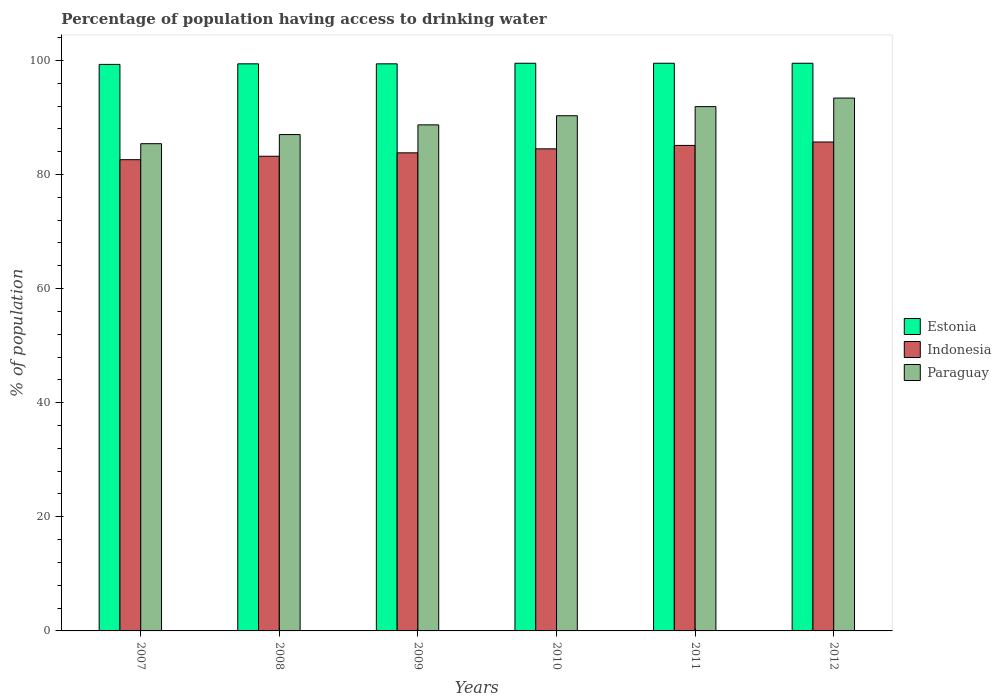How many groups of bars are there?
Give a very brief answer. 6. Are the number of bars per tick equal to the number of legend labels?
Your answer should be compact. Yes. Are the number of bars on each tick of the X-axis equal?
Give a very brief answer. Yes. How many bars are there on the 4th tick from the right?
Keep it short and to the point. 3. What is the percentage of population having access to drinking water in Indonesia in 2008?
Your answer should be very brief. 83.2. Across all years, what is the maximum percentage of population having access to drinking water in Indonesia?
Provide a short and direct response. 85.7. Across all years, what is the minimum percentage of population having access to drinking water in Estonia?
Make the answer very short. 99.3. In which year was the percentage of population having access to drinking water in Indonesia maximum?
Your response must be concise. 2012. What is the total percentage of population having access to drinking water in Indonesia in the graph?
Ensure brevity in your answer.  504.9. What is the difference between the percentage of population having access to drinking water in Indonesia in 2008 and that in 2010?
Give a very brief answer. -1.3. What is the difference between the percentage of population having access to drinking water in Indonesia in 2011 and the percentage of population having access to drinking water in Estonia in 2010?
Offer a very short reply. -14.4. What is the average percentage of population having access to drinking water in Paraguay per year?
Provide a short and direct response. 89.45. In the year 2009, what is the difference between the percentage of population having access to drinking water in Indonesia and percentage of population having access to drinking water in Estonia?
Offer a very short reply. -15.6. In how many years, is the percentage of population having access to drinking water in Paraguay greater than 12 %?
Offer a very short reply. 6. What is the ratio of the percentage of population having access to drinking water in Estonia in 2008 to that in 2012?
Provide a succinct answer. 1. Is the percentage of population having access to drinking water in Estonia in 2007 less than that in 2008?
Make the answer very short. Yes. What is the difference between the highest and the second highest percentage of population having access to drinking water in Indonesia?
Give a very brief answer. 0.6. What is the difference between the highest and the lowest percentage of population having access to drinking water in Estonia?
Offer a very short reply. 0.2. Is the sum of the percentage of population having access to drinking water in Paraguay in 2007 and 2009 greater than the maximum percentage of population having access to drinking water in Indonesia across all years?
Make the answer very short. Yes. What does the 1st bar from the left in 2010 represents?
Your response must be concise. Estonia. What does the 1st bar from the right in 2008 represents?
Ensure brevity in your answer.  Paraguay. How many bars are there?
Your response must be concise. 18. Are all the bars in the graph horizontal?
Ensure brevity in your answer.  No. How many years are there in the graph?
Your answer should be very brief. 6. What is the difference between two consecutive major ticks on the Y-axis?
Ensure brevity in your answer.  20. Are the values on the major ticks of Y-axis written in scientific E-notation?
Provide a short and direct response. No. Does the graph contain any zero values?
Make the answer very short. No. Does the graph contain grids?
Make the answer very short. No. How many legend labels are there?
Offer a terse response. 3. What is the title of the graph?
Provide a succinct answer. Percentage of population having access to drinking water. Does "South Asia" appear as one of the legend labels in the graph?
Your answer should be compact. No. What is the label or title of the X-axis?
Your response must be concise. Years. What is the label or title of the Y-axis?
Your response must be concise. % of population. What is the % of population of Estonia in 2007?
Provide a short and direct response. 99.3. What is the % of population of Indonesia in 2007?
Your answer should be compact. 82.6. What is the % of population of Paraguay in 2007?
Ensure brevity in your answer.  85.4. What is the % of population in Estonia in 2008?
Provide a succinct answer. 99.4. What is the % of population of Indonesia in 2008?
Offer a very short reply. 83.2. What is the % of population of Paraguay in 2008?
Ensure brevity in your answer.  87. What is the % of population of Estonia in 2009?
Ensure brevity in your answer.  99.4. What is the % of population in Indonesia in 2009?
Provide a short and direct response. 83.8. What is the % of population in Paraguay in 2009?
Provide a succinct answer. 88.7. What is the % of population of Estonia in 2010?
Keep it short and to the point. 99.5. What is the % of population of Indonesia in 2010?
Offer a terse response. 84.5. What is the % of population in Paraguay in 2010?
Offer a very short reply. 90.3. What is the % of population in Estonia in 2011?
Your answer should be compact. 99.5. What is the % of population in Indonesia in 2011?
Give a very brief answer. 85.1. What is the % of population in Paraguay in 2011?
Offer a very short reply. 91.9. What is the % of population of Estonia in 2012?
Ensure brevity in your answer.  99.5. What is the % of population of Indonesia in 2012?
Provide a succinct answer. 85.7. What is the % of population of Paraguay in 2012?
Offer a very short reply. 93.4. Across all years, what is the maximum % of population in Estonia?
Your answer should be very brief. 99.5. Across all years, what is the maximum % of population in Indonesia?
Offer a terse response. 85.7. Across all years, what is the maximum % of population in Paraguay?
Make the answer very short. 93.4. Across all years, what is the minimum % of population of Estonia?
Your answer should be compact. 99.3. Across all years, what is the minimum % of population of Indonesia?
Provide a succinct answer. 82.6. Across all years, what is the minimum % of population in Paraguay?
Offer a very short reply. 85.4. What is the total % of population of Estonia in the graph?
Keep it short and to the point. 596.6. What is the total % of population in Indonesia in the graph?
Offer a very short reply. 504.9. What is the total % of population of Paraguay in the graph?
Offer a terse response. 536.7. What is the difference between the % of population in Estonia in 2007 and that in 2008?
Offer a very short reply. -0.1. What is the difference between the % of population in Indonesia in 2007 and that in 2008?
Ensure brevity in your answer.  -0.6. What is the difference between the % of population in Paraguay in 2007 and that in 2008?
Your response must be concise. -1.6. What is the difference between the % of population of Estonia in 2007 and that in 2009?
Make the answer very short. -0.1. What is the difference between the % of population in Indonesia in 2007 and that in 2009?
Keep it short and to the point. -1.2. What is the difference between the % of population in Paraguay in 2007 and that in 2010?
Offer a very short reply. -4.9. What is the difference between the % of population in Paraguay in 2007 and that in 2011?
Keep it short and to the point. -6.5. What is the difference between the % of population in Estonia in 2007 and that in 2012?
Your response must be concise. -0.2. What is the difference between the % of population in Paraguay in 2007 and that in 2012?
Your response must be concise. -8. What is the difference between the % of population of Indonesia in 2008 and that in 2009?
Keep it short and to the point. -0.6. What is the difference between the % of population in Paraguay in 2008 and that in 2009?
Make the answer very short. -1.7. What is the difference between the % of population in Estonia in 2008 and that in 2010?
Ensure brevity in your answer.  -0.1. What is the difference between the % of population in Indonesia in 2008 and that in 2010?
Ensure brevity in your answer.  -1.3. What is the difference between the % of population in Paraguay in 2008 and that in 2010?
Ensure brevity in your answer.  -3.3. What is the difference between the % of population in Estonia in 2008 and that in 2011?
Provide a succinct answer. -0.1. What is the difference between the % of population in Indonesia in 2008 and that in 2011?
Ensure brevity in your answer.  -1.9. What is the difference between the % of population in Estonia in 2008 and that in 2012?
Offer a terse response. -0.1. What is the difference between the % of population of Indonesia in 2008 and that in 2012?
Keep it short and to the point. -2.5. What is the difference between the % of population of Indonesia in 2009 and that in 2010?
Ensure brevity in your answer.  -0.7. What is the difference between the % of population in Paraguay in 2009 and that in 2010?
Give a very brief answer. -1.6. What is the difference between the % of population of Indonesia in 2009 and that in 2011?
Your answer should be compact. -1.3. What is the difference between the % of population in Paraguay in 2009 and that in 2011?
Your answer should be very brief. -3.2. What is the difference between the % of population of Indonesia in 2009 and that in 2012?
Your answer should be compact. -1.9. What is the difference between the % of population in Paraguay in 2009 and that in 2012?
Offer a terse response. -4.7. What is the difference between the % of population of Estonia in 2010 and that in 2012?
Offer a terse response. 0. What is the difference between the % of population in Estonia in 2007 and the % of population in Indonesia in 2009?
Provide a succinct answer. 15.5. What is the difference between the % of population of Indonesia in 2007 and the % of population of Paraguay in 2009?
Make the answer very short. -6.1. What is the difference between the % of population in Estonia in 2007 and the % of population in Paraguay in 2010?
Your answer should be very brief. 9. What is the difference between the % of population of Estonia in 2007 and the % of population of Indonesia in 2011?
Give a very brief answer. 14.2. What is the difference between the % of population in Estonia in 2007 and the % of population in Paraguay in 2011?
Ensure brevity in your answer.  7.4. What is the difference between the % of population in Indonesia in 2007 and the % of population in Paraguay in 2011?
Offer a terse response. -9.3. What is the difference between the % of population of Estonia in 2008 and the % of population of Paraguay in 2009?
Ensure brevity in your answer.  10.7. What is the difference between the % of population in Indonesia in 2008 and the % of population in Paraguay in 2010?
Ensure brevity in your answer.  -7.1. What is the difference between the % of population in Indonesia in 2008 and the % of population in Paraguay in 2011?
Offer a very short reply. -8.7. What is the difference between the % of population in Estonia in 2008 and the % of population in Indonesia in 2012?
Your response must be concise. 13.7. What is the difference between the % of population in Estonia in 2008 and the % of population in Paraguay in 2012?
Keep it short and to the point. 6. What is the difference between the % of population of Estonia in 2009 and the % of population of Indonesia in 2010?
Offer a terse response. 14.9. What is the difference between the % of population in Estonia in 2009 and the % of population in Paraguay in 2010?
Give a very brief answer. 9.1. What is the difference between the % of population of Indonesia in 2009 and the % of population of Paraguay in 2010?
Provide a succinct answer. -6.5. What is the difference between the % of population of Estonia in 2009 and the % of population of Indonesia in 2011?
Provide a short and direct response. 14.3. What is the difference between the % of population in Estonia in 2009 and the % of population in Indonesia in 2012?
Keep it short and to the point. 13.7. What is the difference between the % of population of Estonia in 2010 and the % of population of Paraguay in 2011?
Your answer should be very brief. 7.6. What is the difference between the % of population in Estonia in 2010 and the % of population in Indonesia in 2012?
Your answer should be compact. 13.8. What is the difference between the % of population in Estonia in 2010 and the % of population in Paraguay in 2012?
Keep it short and to the point. 6.1. What is the difference between the % of population of Indonesia in 2010 and the % of population of Paraguay in 2012?
Provide a short and direct response. -8.9. What is the difference between the % of population in Estonia in 2011 and the % of population in Indonesia in 2012?
Your answer should be very brief. 13.8. What is the difference between the % of population of Indonesia in 2011 and the % of population of Paraguay in 2012?
Provide a succinct answer. -8.3. What is the average % of population of Estonia per year?
Give a very brief answer. 99.43. What is the average % of population of Indonesia per year?
Your response must be concise. 84.15. What is the average % of population in Paraguay per year?
Provide a short and direct response. 89.45. In the year 2007, what is the difference between the % of population of Estonia and % of population of Paraguay?
Make the answer very short. 13.9. In the year 2007, what is the difference between the % of population in Indonesia and % of population in Paraguay?
Offer a terse response. -2.8. In the year 2008, what is the difference between the % of population in Estonia and % of population in Indonesia?
Make the answer very short. 16.2. In the year 2008, what is the difference between the % of population in Indonesia and % of population in Paraguay?
Your answer should be very brief. -3.8. In the year 2009, what is the difference between the % of population in Indonesia and % of population in Paraguay?
Ensure brevity in your answer.  -4.9. In the year 2010, what is the difference between the % of population in Estonia and % of population in Indonesia?
Provide a succinct answer. 15. In the year 2010, what is the difference between the % of population in Indonesia and % of population in Paraguay?
Give a very brief answer. -5.8. In the year 2011, what is the difference between the % of population in Estonia and % of population in Indonesia?
Make the answer very short. 14.4. In the year 2011, what is the difference between the % of population in Estonia and % of population in Paraguay?
Keep it short and to the point. 7.6. In the year 2011, what is the difference between the % of population of Indonesia and % of population of Paraguay?
Your answer should be very brief. -6.8. In the year 2012, what is the difference between the % of population of Estonia and % of population of Indonesia?
Your response must be concise. 13.8. In the year 2012, what is the difference between the % of population in Estonia and % of population in Paraguay?
Keep it short and to the point. 6.1. In the year 2012, what is the difference between the % of population in Indonesia and % of population in Paraguay?
Give a very brief answer. -7.7. What is the ratio of the % of population of Estonia in 2007 to that in 2008?
Keep it short and to the point. 1. What is the ratio of the % of population in Paraguay in 2007 to that in 2008?
Make the answer very short. 0.98. What is the ratio of the % of population of Estonia in 2007 to that in 2009?
Provide a succinct answer. 1. What is the ratio of the % of population in Indonesia in 2007 to that in 2009?
Provide a short and direct response. 0.99. What is the ratio of the % of population in Paraguay in 2007 to that in 2009?
Make the answer very short. 0.96. What is the ratio of the % of population of Indonesia in 2007 to that in 2010?
Your answer should be compact. 0.98. What is the ratio of the % of population of Paraguay in 2007 to that in 2010?
Offer a terse response. 0.95. What is the ratio of the % of population of Indonesia in 2007 to that in 2011?
Keep it short and to the point. 0.97. What is the ratio of the % of population in Paraguay in 2007 to that in 2011?
Your response must be concise. 0.93. What is the ratio of the % of population of Estonia in 2007 to that in 2012?
Ensure brevity in your answer.  1. What is the ratio of the % of population in Indonesia in 2007 to that in 2012?
Your answer should be very brief. 0.96. What is the ratio of the % of population of Paraguay in 2007 to that in 2012?
Provide a short and direct response. 0.91. What is the ratio of the % of population in Paraguay in 2008 to that in 2009?
Your response must be concise. 0.98. What is the ratio of the % of population of Estonia in 2008 to that in 2010?
Ensure brevity in your answer.  1. What is the ratio of the % of population in Indonesia in 2008 to that in 2010?
Your answer should be compact. 0.98. What is the ratio of the % of population of Paraguay in 2008 to that in 2010?
Ensure brevity in your answer.  0.96. What is the ratio of the % of population of Estonia in 2008 to that in 2011?
Ensure brevity in your answer.  1. What is the ratio of the % of population of Indonesia in 2008 to that in 2011?
Offer a terse response. 0.98. What is the ratio of the % of population in Paraguay in 2008 to that in 2011?
Give a very brief answer. 0.95. What is the ratio of the % of population of Indonesia in 2008 to that in 2012?
Offer a terse response. 0.97. What is the ratio of the % of population in Paraguay in 2008 to that in 2012?
Offer a terse response. 0.93. What is the ratio of the % of population in Paraguay in 2009 to that in 2010?
Offer a very short reply. 0.98. What is the ratio of the % of population of Estonia in 2009 to that in 2011?
Offer a very short reply. 1. What is the ratio of the % of population in Indonesia in 2009 to that in 2011?
Keep it short and to the point. 0.98. What is the ratio of the % of population of Paraguay in 2009 to that in 2011?
Your response must be concise. 0.97. What is the ratio of the % of population of Estonia in 2009 to that in 2012?
Offer a terse response. 1. What is the ratio of the % of population of Indonesia in 2009 to that in 2012?
Your answer should be compact. 0.98. What is the ratio of the % of population of Paraguay in 2009 to that in 2012?
Provide a succinct answer. 0.95. What is the ratio of the % of population of Indonesia in 2010 to that in 2011?
Provide a succinct answer. 0.99. What is the ratio of the % of population in Paraguay in 2010 to that in 2011?
Keep it short and to the point. 0.98. What is the ratio of the % of population of Paraguay in 2010 to that in 2012?
Give a very brief answer. 0.97. What is the ratio of the % of population in Paraguay in 2011 to that in 2012?
Offer a very short reply. 0.98. What is the difference between the highest and the second highest % of population of Paraguay?
Offer a very short reply. 1.5. What is the difference between the highest and the lowest % of population of Indonesia?
Your response must be concise. 3.1. What is the difference between the highest and the lowest % of population of Paraguay?
Offer a terse response. 8. 